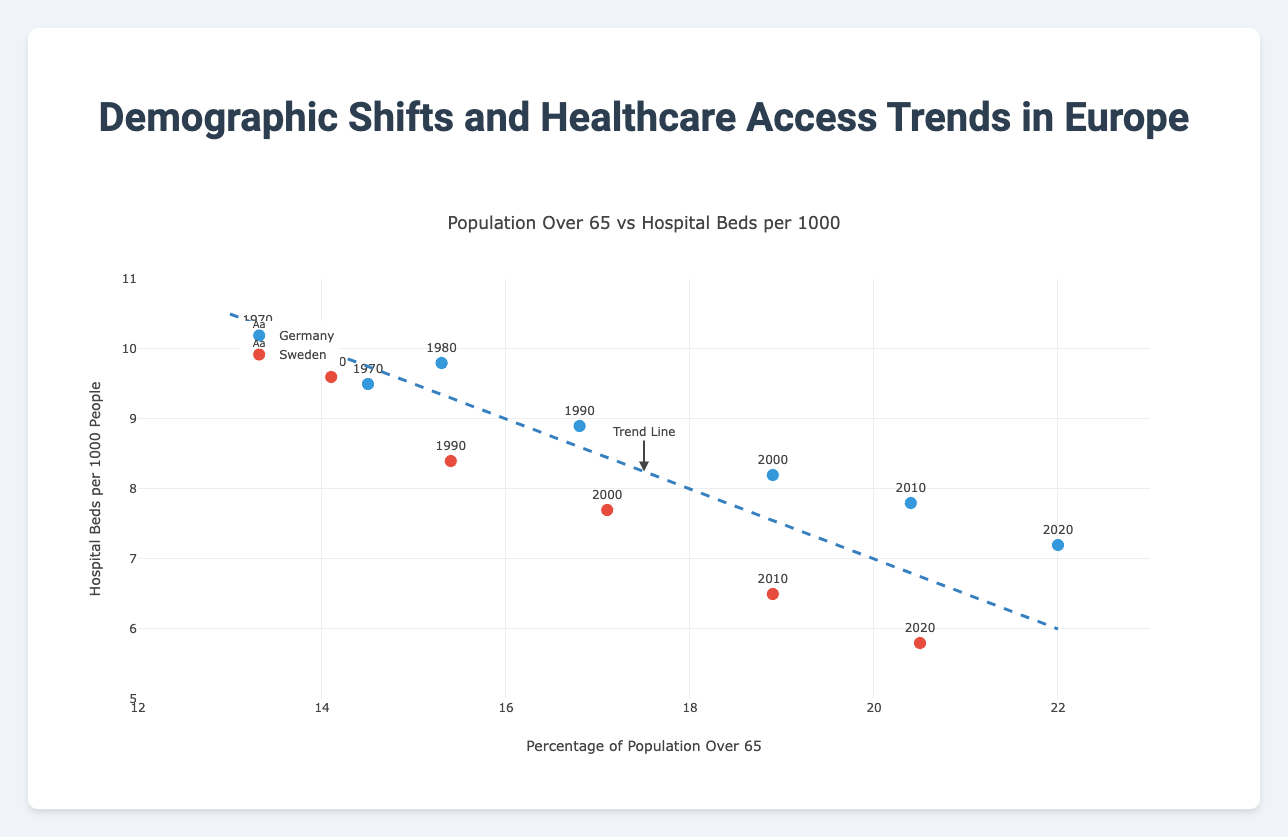What is the title of the figure? The title is displayed at the top of the figure, which reads "Population Over 65 vs Hospital Beds per 1000".
Answer: Population Over 65 vs Hospital Beds per 1000 How many countries' data are represented on the plot? There are distinct markers and labels that indicate different countries. By examining the marker labels, it's clear that two countries are represented: Germany and Sweden.
Answer: Two What is the y-axis range? The y-axis ticks range from 5 to 11, as observed from the axis labels on the left side of the plot.
Answer: 5 to 11 Which country had more hospital beds per 1000 people in 1980? The data points are labelled by year. By locating the year 1980 and comparing the y-values for both Germany and Sweden, Sweden had more hospital beds per 1000 people (9.6 compared to Germany's 9.8).
Answer: Sweden How does hospital bed availability change as the percentage of the population over 65 increases? The trend line added to the plot slopes downwards from left to right, indicating that as the percentage of the population over 65 rises, the number of hospital beds per 1000 people declines.
Answer: Decreases Which year had the highest percentage of the population over 65 in Sweden? By examining the x-axis values for the data points labeled Sweden, the highest x-value corresponds to the year 2020.
Answer: 2020 What is the trend in life expectancy from 1970 to 2020 for Germany? The step-by-step values provided are 70.8 (1970), 72.4 (1980), 74.6 (1990), 77.0 (2000), 79.3 (2010), and 80.6 (2020). These values show a general increase in life expectancy over the years.
Answer: Increasing What is the difference in hospital beds per 1000 between Germany and Sweden in 2010? For the year 2010, Germany has 7.8 hospital beds per 1000 and Sweden has 6.5. The difference is calculated as 7.8 - 6.5.
Answer: 1.3 Which country experienced a greater decline in hospital beds per 1000 from 1970 to 2020? For Germany, the change is 9.5 (1970) - 7.2 (2020). For Sweden, it is 10.2 (1970) - 5.8 (2020). The absolute decrease is greater for Sweden.
Answer: Sweden Do both countries show similar trends in the relationship between the percentage of the population over 65 and hospital beds per 1000? Both countries' data points follow the general downward sloping trend indicated by the trend line. This suggests that for both countries, an increasing percentage of the population over 65 is associated with a decrease in hospital beds per 1000.
Answer: Yes 